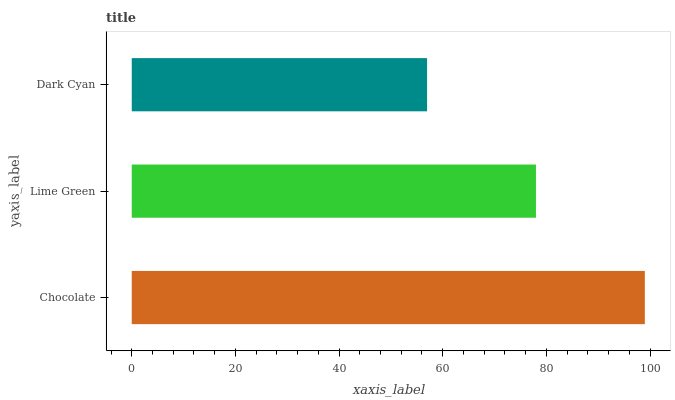Is Dark Cyan the minimum?
Answer yes or no. Yes. Is Chocolate the maximum?
Answer yes or no. Yes. Is Lime Green the minimum?
Answer yes or no. No. Is Lime Green the maximum?
Answer yes or no. No. Is Chocolate greater than Lime Green?
Answer yes or no. Yes. Is Lime Green less than Chocolate?
Answer yes or no. Yes. Is Lime Green greater than Chocolate?
Answer yes or no. No. Is Chocolate less than Lime Green?
Answer yes or no. No. Is Lime Green the high median?
Answer yes or no. Yes. Is Lime Green the low median?
Answer yes or no. Yes. Is Dark Cyan the high median?
Answer yes or no. No. Is Chocolate the low median?
Answer yes or no. No. 